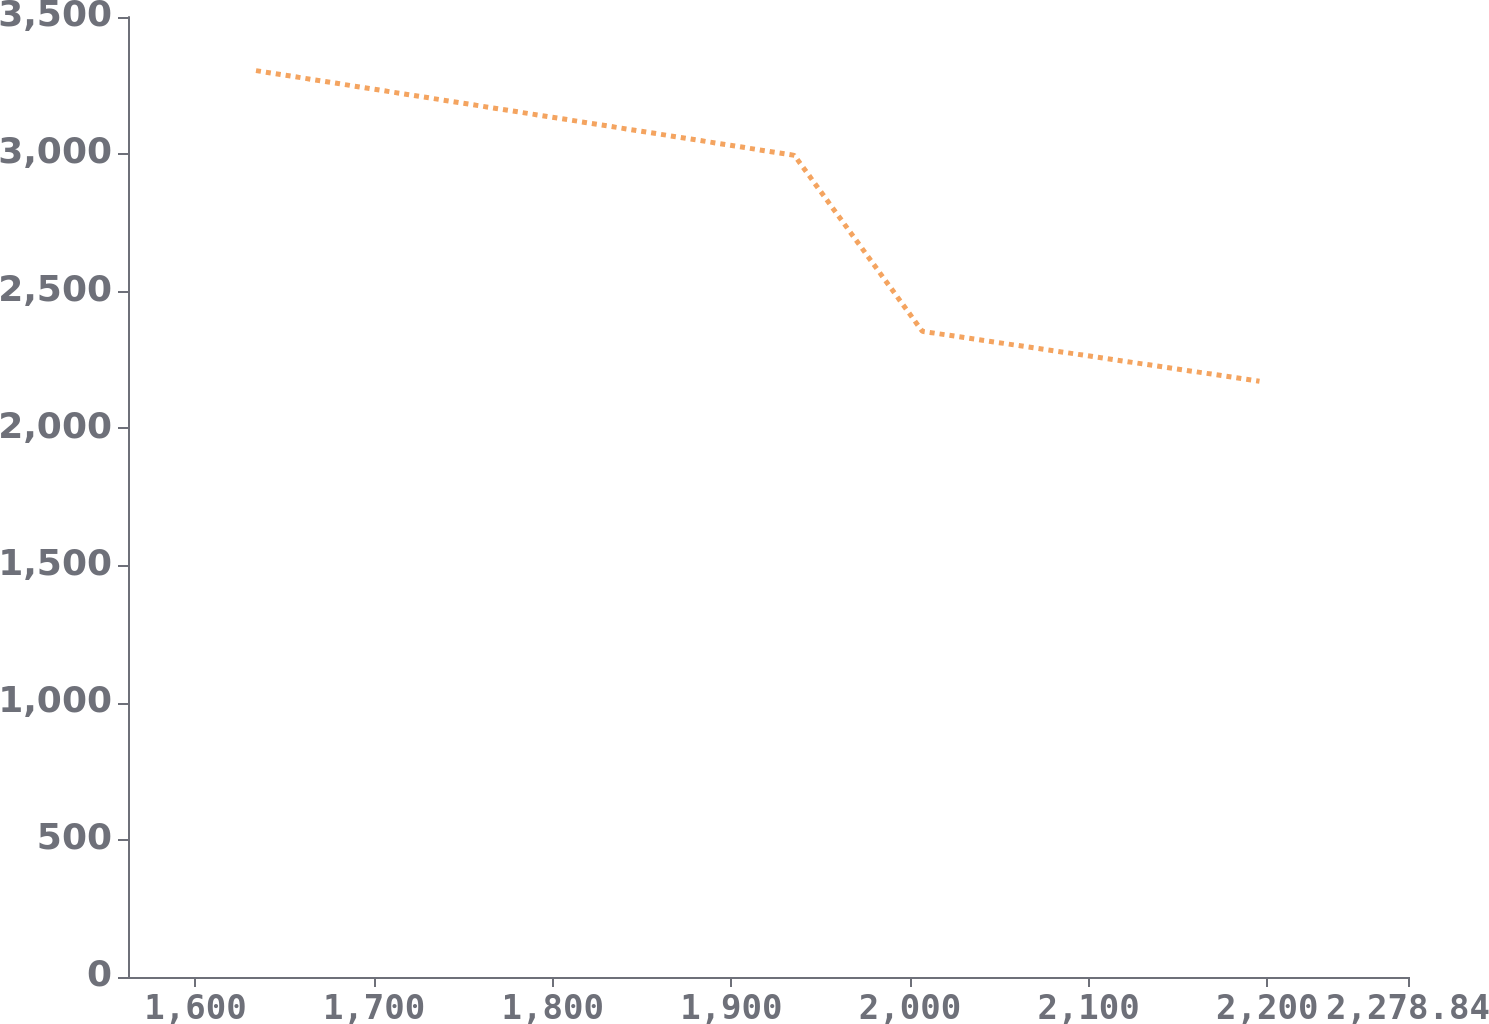<chart> <loc_0><loc_0><loc_500><loc_500><line_chart><ecel><fcel>Unnamed: 1<nl><fcel>1633.9<fcel>3304.49<nl><fcel>1935.3<fcel>2995.61<nl><fcel>2006.96<fcel>2353.97<nl><fcel>2195.7<fcel>2172.31<nl><fcel>2350.5<fcel>1754.82<nl></chart> 